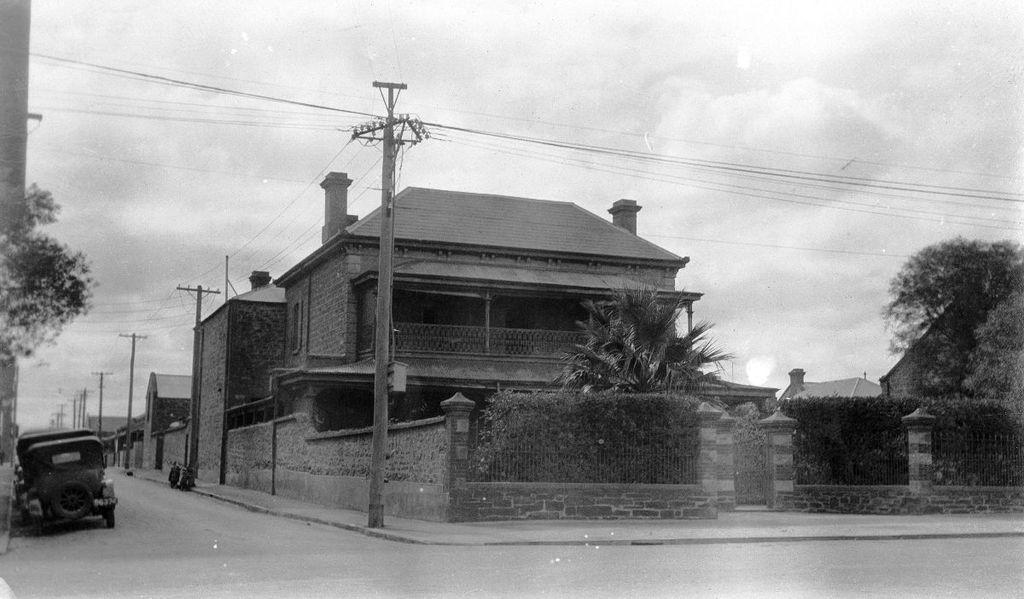Please provide a concise description of this image. In this black and white picture few vehicles are on the road. There are few poles connected with wires are on the pavement. Few plants and trees are behind the fence. Behind the poles there are few houses. Left side there is a tree. Top of image there is sky. 